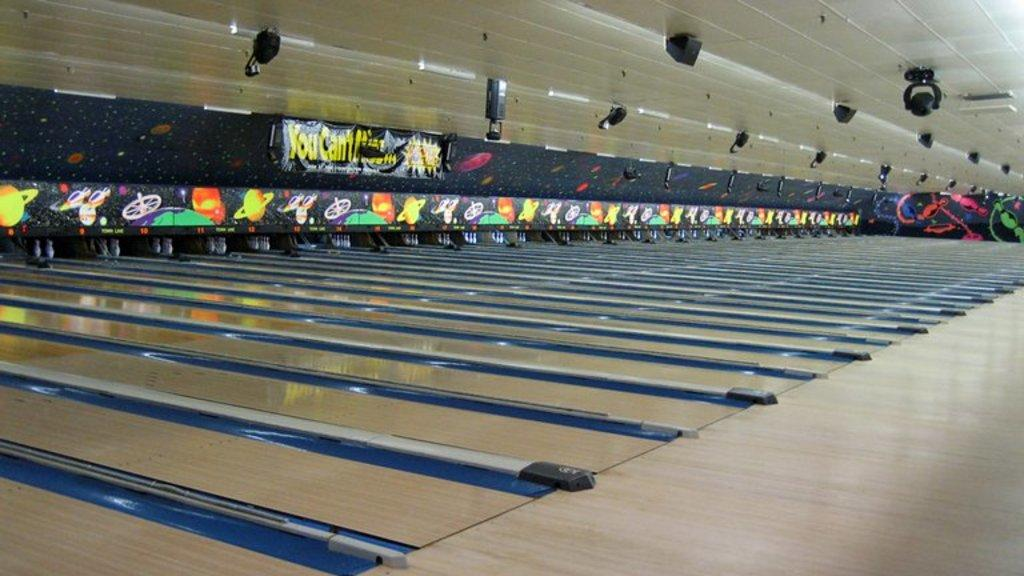What is located above the bowling track in the image? There is a ceiling with lights in the image. What can be seen in the center of the image? There is a bowling track in the center of the image. What type of flooring is present at the bottom of the image? There is wooden flooring at the bottom of the image. Can you see any plantation in the image? There is no plantation present in the image. What type of breakfast is being served on the bowling track? There is no breakfast being served in the image; it features a bowling track and a ceiling with lights. 